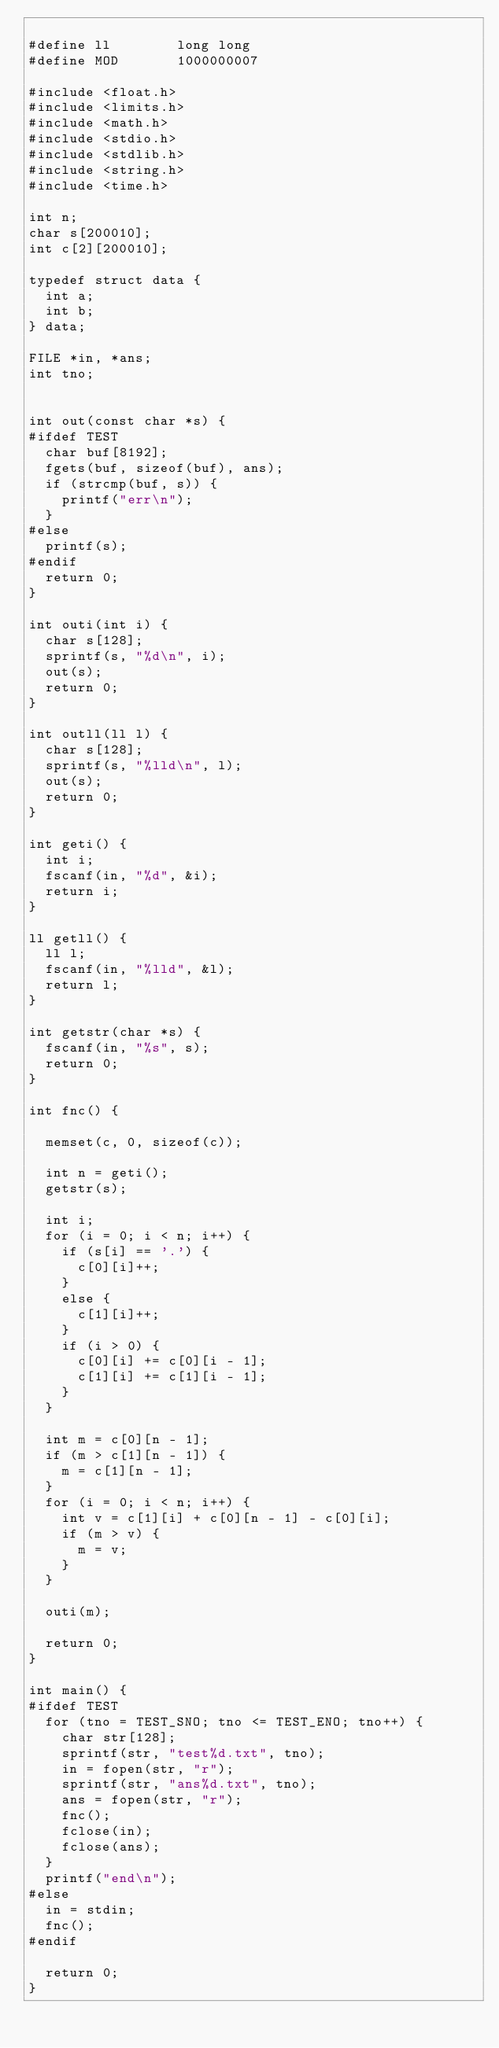Convert code to text. <code><loc_0><loc_0><loc_500><loc_500><_C_>
#define ll				long long
#define MOD				1000000007

#include <float.h>
#include <limits.h>
#include <math.h>
#include <stdio.h>
#include <stdlib.h>
#include <string.h>
#include <time.h>

int n;
char s[200010];
int c[2][200010];

typedef struct data {
	int a;
	int b;
} data;

FILE *in, *ans;
int tno;


int out(const char *s) {
#ifdef TEST
	char buf[8192];
	fgets(buf, sizeof(buf), ans);
	if (strcmp(buf, s)) {
		printf("err\n");
	}
#else
	printf(s);
#endif
	return 0;
}

int outi(int i) {
	char s[128];
	sprintf(s, "%d\n", i);
	out(s);
	return 0;
}

int outll(ll l) {
	char s[128];
	sprintf(s, "%lld\n", l);
	out(s);
	return 0;
}

int geti() {
	int i;
	fscanf(in, "%d", &i);
	return i;
}

ll getll() {
	ll l;
	fscanf(in, "%lld", &l);
	return l;
}

int getstr(char *s) {
	fscanf(in, "%s", s);
	return 0;
}

int fnc() {

	memset(c, 0, sizeof(c));

	int n = geti();
	getstr(s);

	int i;
	for (i = 0; i < n; i++) {
		if (s[i] == '.') {
			c[0][i]++;
		}
		else {
			c[1][i]++;
		}
		if (i > 0) {
			c[0][i] += c[0][i - 1];
			c[1][i] += c[1][i - 1];
		}
	}

	int m = c[0][n - 1];
	if (m > c[1][n - 1]) {
		m = c[1][n - 1];
	}
	for (i = 0; i < n; i++) {
		int v = c[1][i] + c[0][n - 1] - c[0][i];
		if (m > v) {
			m = v;
		}
	}

	outi(m);

	return 0;
}

int main() {
#ifdef TEST
	for (tno = TEST_SNO; tno <= TEST_ENO; tno++) {
		char str[128];
		sprintf(str, "test%d.txt", tno);
		in = fopen(str, "r");
		sprintf(str, "ans%d.txt", tno);
		ans = fopen(str, "r");
		fnc();
		fclose(in);
		fclose(ans);
	}
	printf("end\n");
#else
	in = stdin;
	fnc();
#endif

	return 0;
}
</code> 